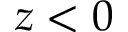<formula> <loc_0><loc_0><loc_500><loc_500>z < 0</formula> 